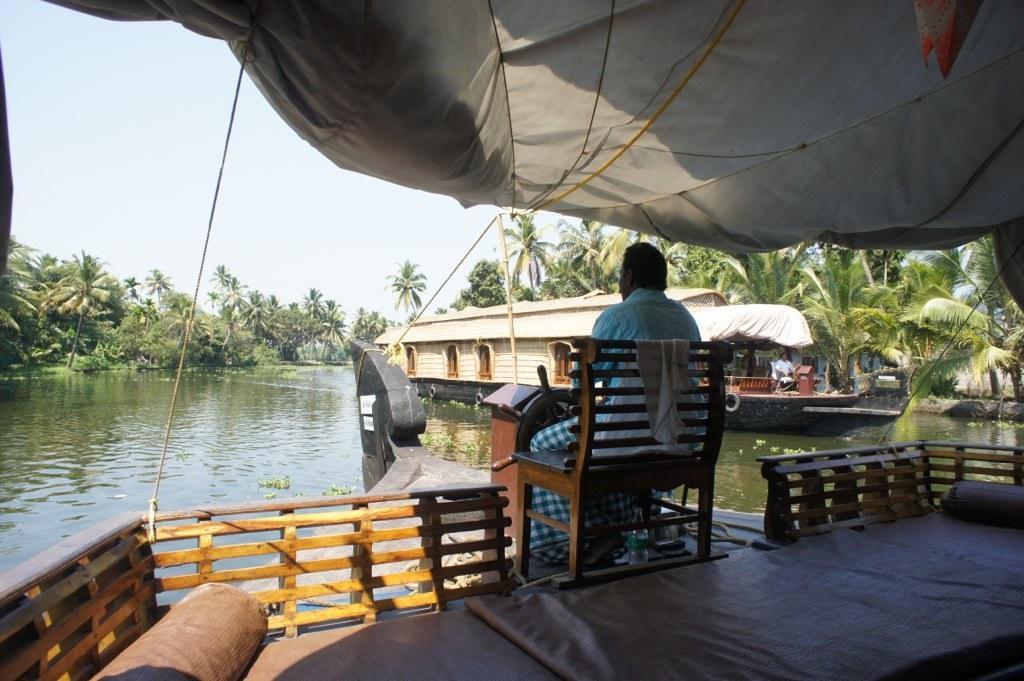Could you give a brief overview of what you see in this image? In this image we can see a man sitting on the chair and riding the boat. In the background we can see a boat, river and many trees. 